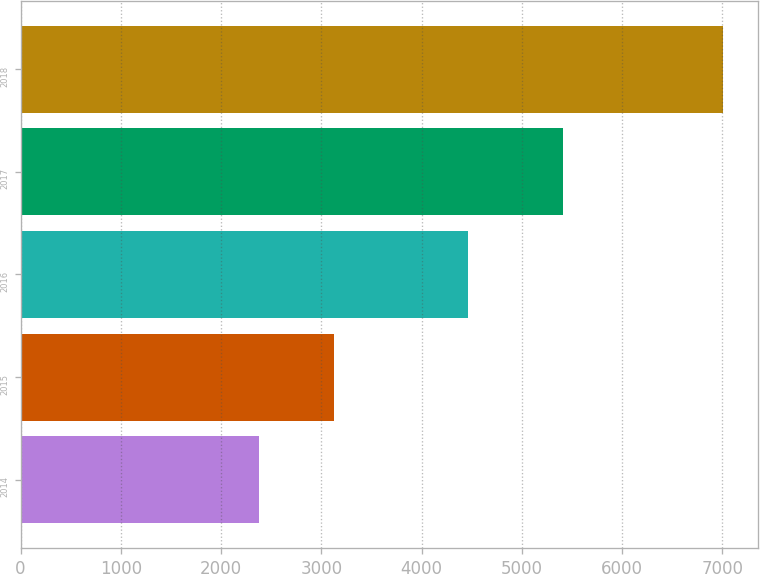Convert chart. <chart><loc_0><loc_0><loc_500><loc_500><bar_chart><fcel>2014<fcel>2015<fcel>2016<fcel>2017<fcel>2018<nl><fcel>2382<fcel>3129<fcel>4466<fcel>5415<fcel>7006<nl></chart> 